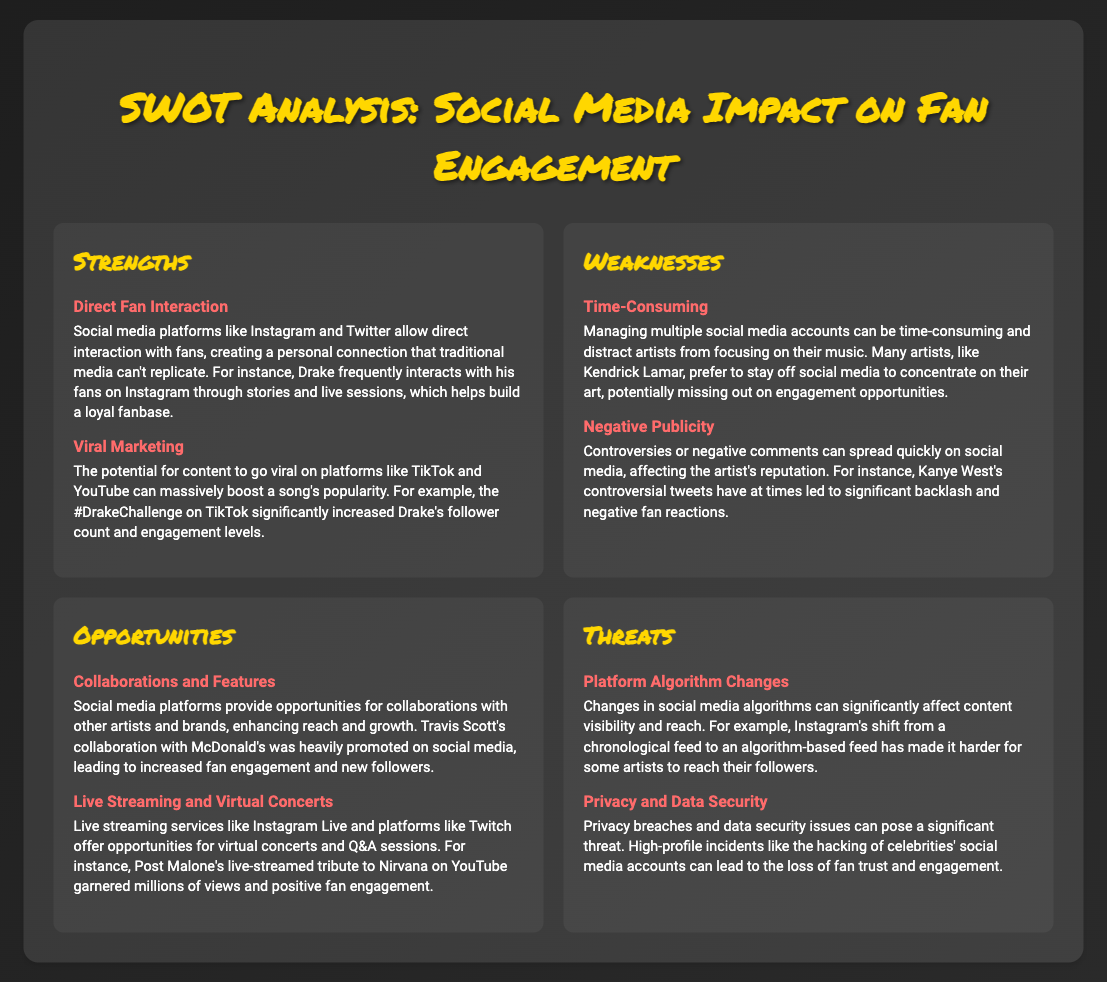what is a significant strength of social media for fan engagement? The document lists "Direct Fan Interaction" as a major strength because it allows for personal connections with fans.
Answer: Direct Fan Interaction which artist's negative publicity is mentioned as an example? Kanye West is cited in the document as an artist whose controversies can lead to negative fan reactions.
Answer: Kanye West what opportunity is identified related to virtual events? "Live Streaming and Virtual Concerts" are highlighted as opportunities for engagement and growth.
Answer: Live Streaming and Virtual Concerts what change in social media has affected artists' visibility? The document discusses "Platform Algorithm Changes" that impact content visibility and reach.
Answer: Platform Algorithm Changes which artist’s collaboration with a brand is noted in the opportunities section? Travis Scott's collaboration with McDonald's is mentioned as an opportunity for increased fan engagement.
Answer: Travis Scott how does social media allow artists to build their fanbase? The document states that viral content on platforms like TikTok can massively boost a song's popularity, thus building a fanbase.
Answer: Viral Marketing what is a noted weakness regarding social media management? The document points out that managing multiple social media accounts can be "Time-Consuming."
Answer: Time-Consuming what factor can lead to a loss of fan trust? The document states that "Privacy and Data Security" issues can threaten fan trust.
Answer: Privacy and Data Security which platform is mentioned for direct interaction with fans? Instagram is referenced in the document as a platform for direct fan engagement.
Answer: Instagram 